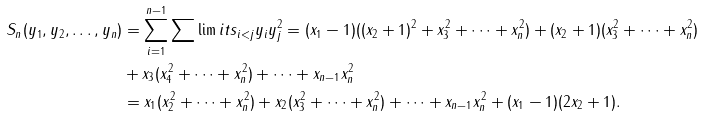Convert formula to latex. <formula><loc_0><loc_0><loc_500><loc_500>S _ { n } ( y _ { 1 } , y _ { 2 } , \dots , y _ { n } ) & = \sum _ { i = 1 } ^ { n - 1 } \sum \lim i t s _ { i < j } y _ { i } y _ { j } ^ { 2 } = ( x _ { 1 } - 1 ) ( ( x _ { 2 } + 1 ) ^ { 2 } + x _ { 3 } ^ { 2 } + \cdots + x _ { n } ^ { 2 } ) + ( x _ { 2 } + 1 ) ( x _ { 3 } ^ { 2 } + \cdots + x _ { n } ^ { 2 } ) \\ & + x _ { 3 } ( x _ { 4 } ^ { 2 } + \cdots + x _ { n } ^ { 2 } ) + \cdots + x _ { n - 1 } x _ { n } ^ { 2 } \\ & = x _ { 1 } ( x _ { 2 } ^ { 2 } + \cdots + x _ { n } ^ { 2 } ) + x _ { 2 } ( x _ { 3 } ^ { 2 } + \cdots + x _ { n } ^ { 2 } ) + \cdots + x _ { n - 1 } x _ { n } ^ { 2 } + ( x _ { 1 } - 1 ) ( 2 x _ { 2 } + 1 ) .</formula> 